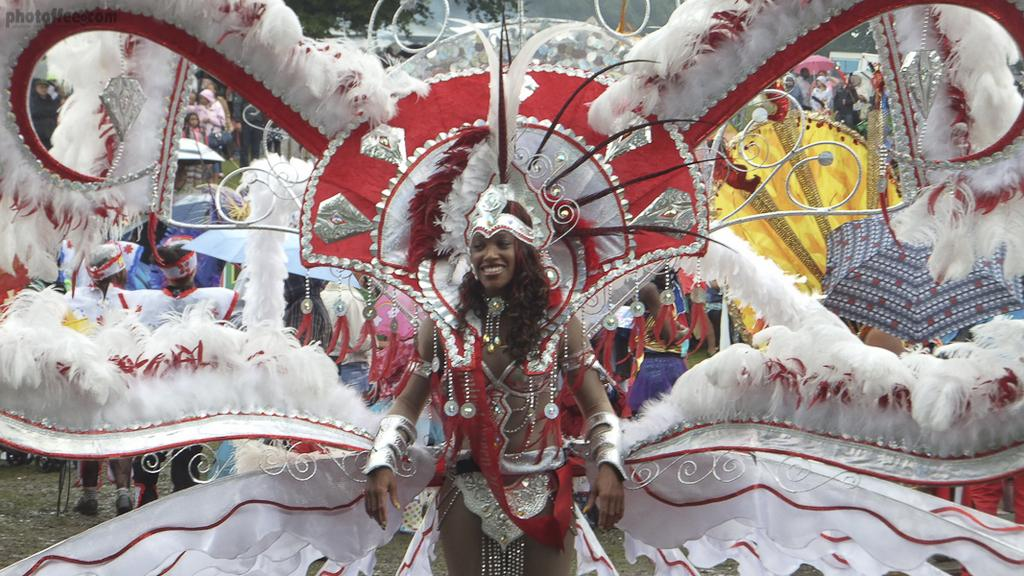Who is the main subject in the image? There is a woman in the image. What is the woman wearing? The woman is wearing a costume. What does the costume resemble? The costume resembles an octopus. What colors are used in the costume? The costume is in red and white colors. Can you describe the background of the image? There are many people in the background of the image. What type of harbor can be seen in the background of the image? There is no harbor present in the image; it features a woman wearing an octopus costume and many people in the background. 